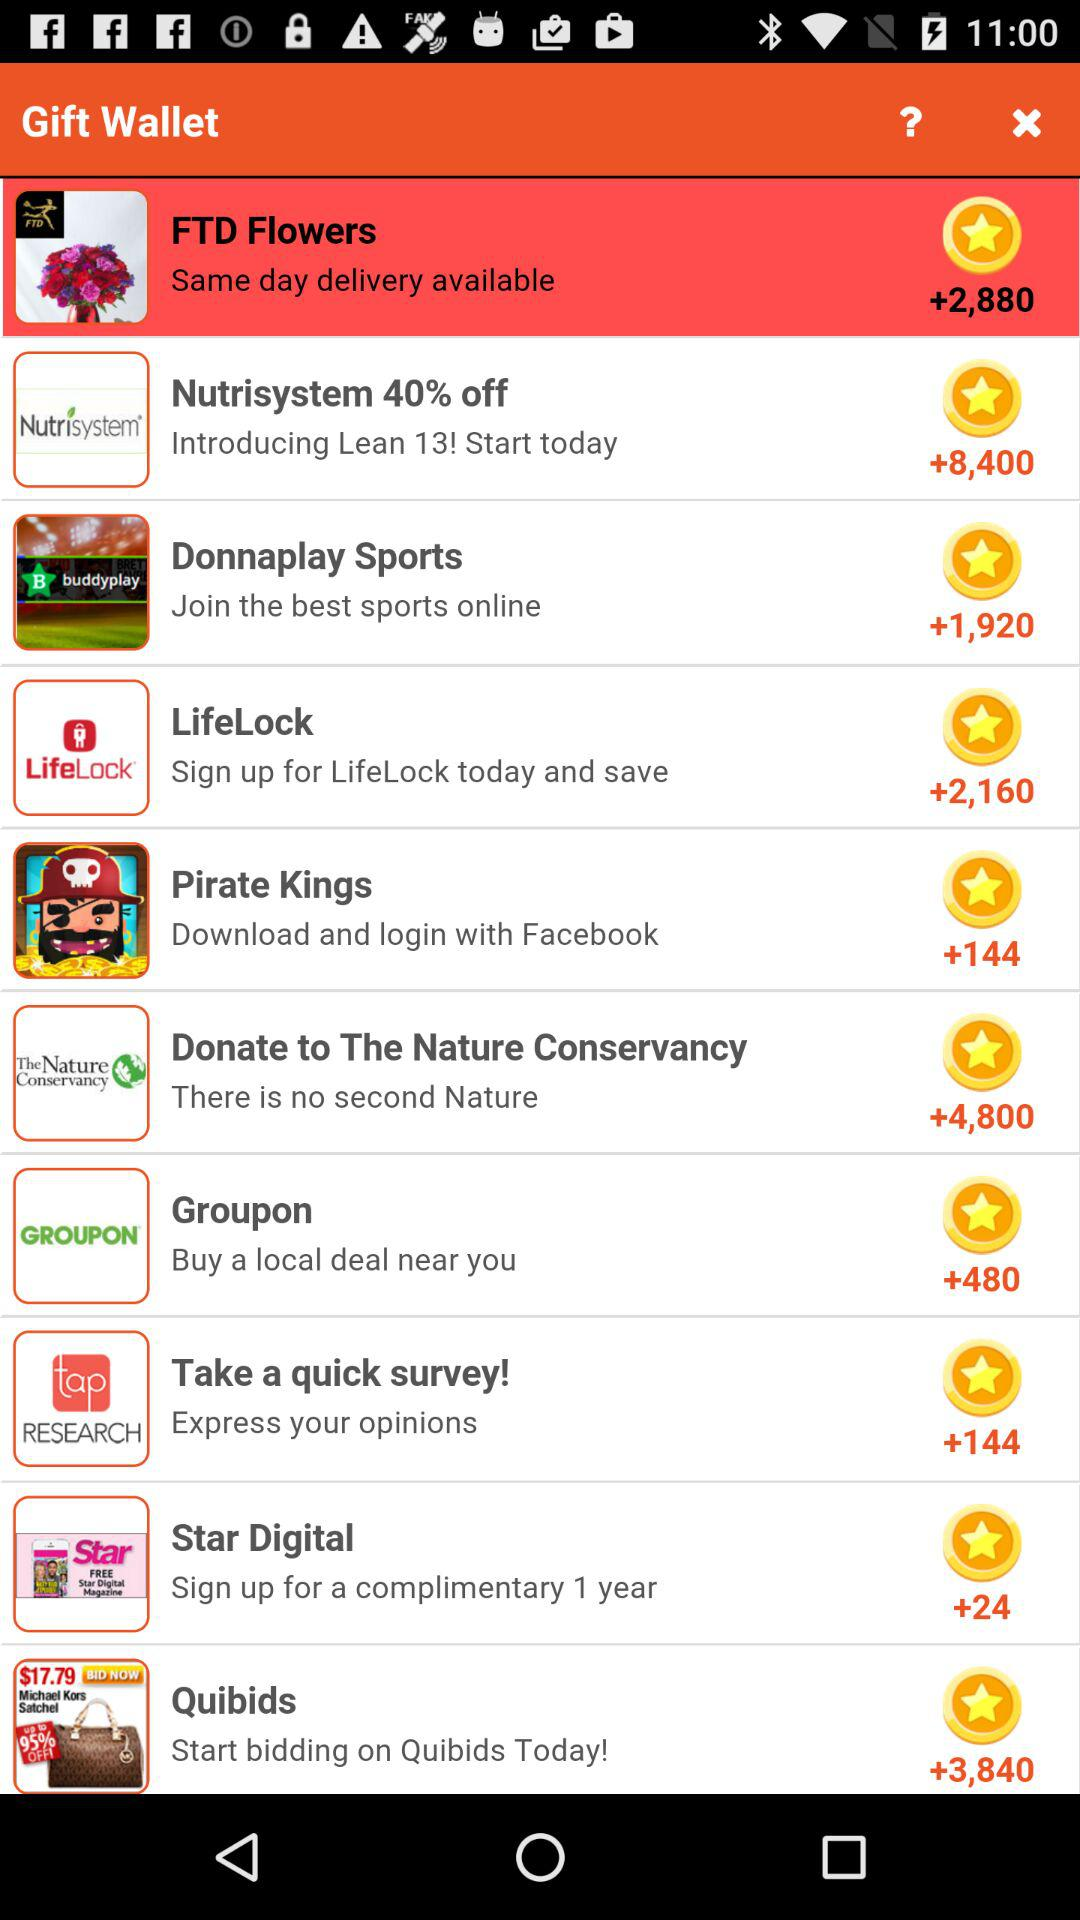What is the number of points on LifeLock? The number of points is +2,160. 